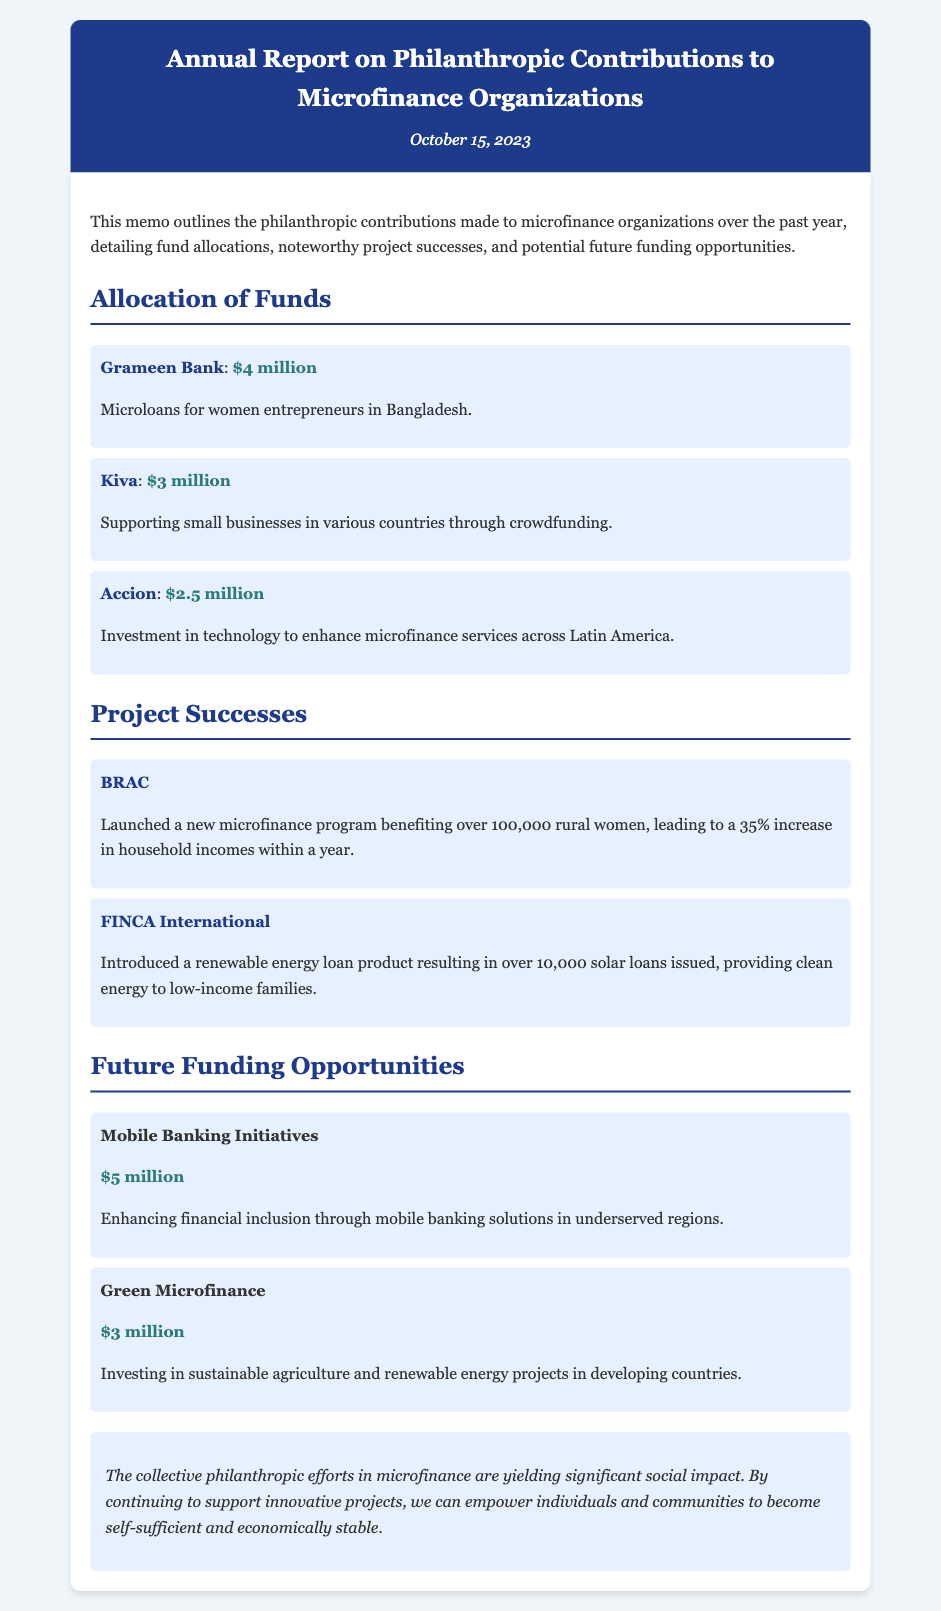What is the date of the report? The date is indicated in the header of the document, which is October 15, 2023.
Answer: October 15, 2023 How much was allocated to Grameen Bank? The allocation amount for Grameen Bank is specified in the "Allocation of Funds" section.
Answer: $4 million What project did BRAC launch? The document mentions that BRAC launched a microfinance program benefiting rural women, detailed in the "Project Successes" section.
Answer: A new microfinance program What is the potential funding amount for Mobile Banking Initiatives? The potential funding amount is provided in the "Future Funding Opportunities" section for the Mobile Banking Initiatives.
Answer: $5 million Which organization introduced a renewable energy loan product? The document specifies that FINCA International introduced this loan product in the "Project Successes" section.
Answer: FINCA International What was the percentage increase in household incomes due to BRAC's new program? The percentage increase is stated in the description of BRAC's project success.
Answer: 35% What type of microfinance initiative is suggested for $3 million? The document provides a suggestion for funding in the "Future Funding Opportunities" section, specifying the type of initiative.
Answer: Green Microfinance 